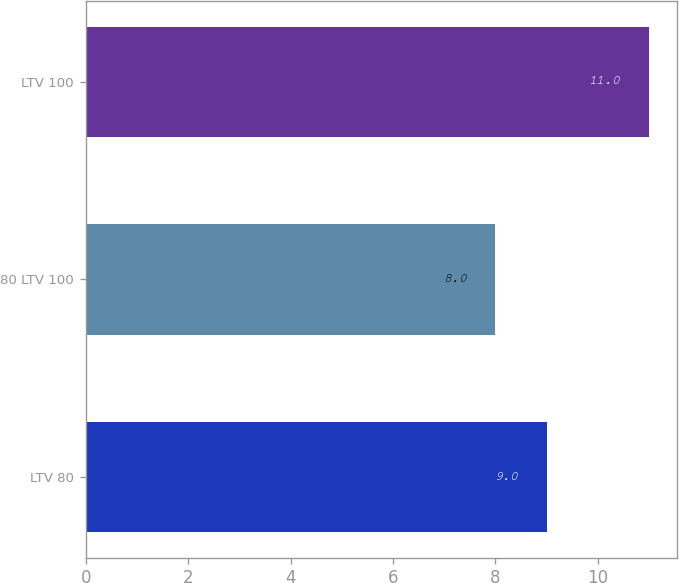Convert chart to OTSL. <chart><loc_0><loc_0><loc_500><loc_500><bar_chart><fcel>LTV 80<fcel>80 LTV 100<fcel>LTV 100<nl><fcel>9<fcel>8<fcel>11<nl></chart> 